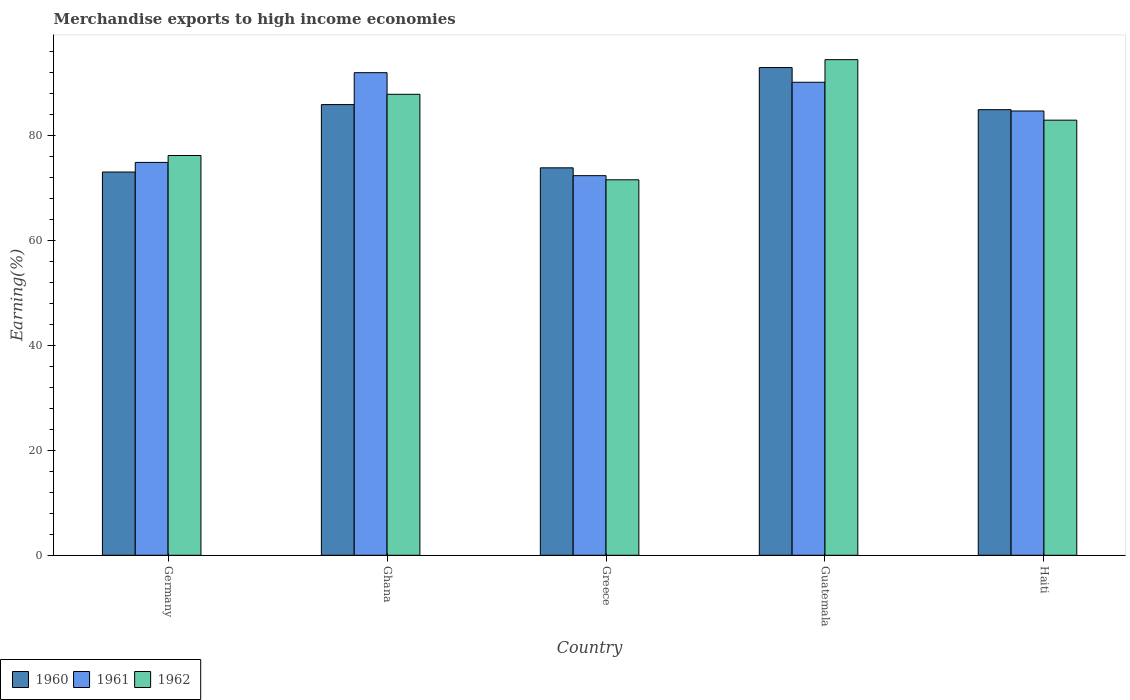How many different coloured bars are there?
Your response must be concise. 3. How many groups of bars are there?
Offer a terse response. 5. Are the number of bars per tick equal to the number of legend labels?
Offer a terse response. Yes. Are the number of bars on each tick of the X-axis equal?
Ensure brevity in your answer.  Yes. How many bars are there on the 4th tick from the left?
Ensure brevity in your answer.  3. In how many cases, is the number of bars for a given country not equal to the number of legend labels?
Keep it short and to the point. 0. What is the percentage of amount earned from merchandise exports in 1962 in Haiti?
Provide a short and direct response. 82.89. Across all countries, what is the maximum percentage of amount earned from merchandise exports in 1960?
Offer a very short reply. 92.91. Across all countries, what is the minimum percentage of amount earned from merchandise exports in 1961?
Provide a short and direct response. 72.31. In which country was the percentage of amount earned from merchandise exports in 1960 maximum?
Provide a succinct answer. Guatemala. In which country was the percentage of amount earned from merchandise exports in 1960 minimum?
Make the answer very short. Germany. What is the total percentage of amount earned from merchandise exports in 1960 in the graph?
Make the answer very short. 410.46. What is the difference between the percentage of amount earned from merchandise exports in 1960 in Ghana and that in Greece?
Keep it short and to the point. 12.05. What is the difference between the percentage of amount earned from merchandise exports in 1960 in Germany and the percentage of amount earned from merchandise exports in 1961 in Ghana?
Give a very brief answer. -18.93. What is the average percentage of amount earned from merchandise exports in 1960 per country?
Offer a terse response. 82.09. What is the difference between the percentage of amount earned from merchandise exports of/in 1960 and percentage of amount earned from merchandise exports of/in 1961 in Germany?
Provide a succinct answer. -1.83. In how many countries, is the percentage of amount earned from merchandise exports in 1962 greater than 16 %?
Provide a succinct answer. 5. What is the ratio of the percentage of amount earned from merchandise exports in 1961 in Ghana to that in Guatemala?
Keep it short and to the point. 1.02. Is the difference between the percentage of amount earned from merchandise exports in 1960 in Germany and Haiti greater than the difference between the percentage of amount earned from merchandise exports in 1961 in Germany and Haiti?
Offer a very short reply. No. What is the difference between the highest and the second highest percentage of amount earned from merchandise exports in 1962?
Make the answer very short. -11.53. What is the difference between the highest and the lowest percentage of amount earned from merchandise exports in 1961?
Your answer should be very brief. 19.62. In how many countries, is the percentage of amount earned from merchandise exports in 1960 greater than the average percentage of amount earned from merchandise exports in 1960 taken over all countries?
Offer a terse response. 3. Is the sum of the percentage of amount earned from merchandise exports in 1962 in Greece and Guatemala greater than the maximum percentage of amount earned from merchandise exports in 1960 across all countries?
Ensure brevity in your answer.  Yes. What does the 1st bar from the left in Ghana represents?
Ensure brevity in your answer.  1960. What does the 3rd bar from the right in Germany represents?
Your answer should be very brief. 1960. How many bars are there?
Your answer should be very brief. 15. Are the values on the major ticks of Y-axis written in scientific E-notation?
Make the answer very short. No. Does the graph contain grids?
Give a very brief answer. No. Where does the legend appear in the graph?
Keep it short and to the point. Bottom left. How many legend labels are there?
Ensure brevity in your answer.  3. What is the title of the graph?
Provide a succinct answer. Merchandise exports to high income economies. Does "1974" appear as one of the legend labels in the graph?
Provide a succinct answer. No. What is the label or title of the X-axis?
Provide a short and direct response. Country. What is the label or title of the Y-axis?
Make the answer very short. Earning(%). What is the Earning(%) in 1960 in Germany?
Your response must be concise. 73.01. What is the Earning(%) in 1961 in Germany?
Your answer should be very brief. 74.84. What is the Earning(%) in 1962 in Germany?
Your answer should be very brief. 76.15. What is the Earning(%) of 1960 in Ghana?
Keep it short and to the point. 85.85. What is the Earning(%) of 1961 in Ghana?
Provide a succinct answer. 91.93. What is the Earning(%) in 1962 in Ghana?
Ensure brevity in your answer.  87.82. What is the Earning(%) in 1960 in Greece?
Your answer should be compact. 73.81. What is the Earning(%) of 1961 in Greece?
Offer a terse response. 72.31. What is the Earning(%) in 1962 in Greece?
Provide a short and direct response. 71.53. What is the Earning(%) in 1960 in Guatemala?
Keep it short and to the point. 92.91. What is the Earning(%) in 1961 in Guatemala?
Offer a very short reply. 90.11. What is the Earning(%) in 1962 in Guatemala?
Keep it short and to the point. 94.41. What is the Earning(%) of 1960 in Haiti?
Make the answer very short. 84.88. What is the Earning(%) in 1961 in Haiti?
Offer a very short reply. 84.63. What is the Earning(%) of 1962 in Haiti?
Provide a succinct answer. 82.89. Across all countries, what is the maximum Earning(%) in 1960?
Provide a succinct answer. 92.91. Across all countries, what is the maximum Earning(%) in 1961?
Provide a short and direct response. 91.93. Across all countries, what is the maximum Earning(%) in 1962?
Give a very brief answer. 94.41. Across all countries, what is the minimum Earning(%) of 1960?
Your answer should be very brief. 73.01. Across all countries, what is the minimum Earning(%) in 1961?
Provide a succinct answer. 72.31. Across all countries, what is the minimum Earning(%) of 1962?
Offer a terse response. 71.53. What is the total Earning(%) in 1960 in the graph?
Offer a terse response. 410.46. What is the total Earning(%) of 1961 in the graph?
Make the answer very short. 413.83. What is the total Earning(%) in 1962 in the graph?
Offer a terse response. 412.8. What is the difference between the Earning(%) of 1960 in Germany and that in Ghana?
Ensure brevity in your answer.  -12.85. What is the difference between the Earning(%) in 1961 in Germany and that in Ghana?
Keep it short and to the point. -17.09. What is the difference between the Earning(%) in 1962 in Germany and that in Ghana?
Ensure brevity in your answer.  -11.66. What is the difference between the Earning(%) in 1960 in Germany and that in Greece?
Provide a short and direct response. -0.8. What is the difference between the Earning(%) in 1961 in Germany and that in Greece?
Ensure brevity in your answer.  2.52. What is the difference between the Earning(%) of 1962 in Germany and that in Greece?
Ensure brevity in your answer.  4.63. What is the difference between the Earning(%) of 1960 in Germany and that in Guatemala?
Offer a very short reply. -19.9. What is the difference between the Earning(%) of 1961 in Germany and that in Guatemala?
Keep it short and to the point. -15.27. What is the difference between the Earning(%) in 1962 in Germany and that in Guatemala?
Make the answer very short. -18.26. What is the difference between the Earning(%) in 1960 in Germany and that in Haiti?
Your response must be concise. -11.88. What is the difference between the Earning(%) of 1961 in Germany and that in Haiti?
Provide a succinct answer. -9.8. What is the difference between the Earning(%) in 1962 in Germany and that in Haiti?
Ensure brevity in your answer.  -6.73. What is the difference between the Earning(%) of 1960 in Ghana and that in Greece?
Provide a succinct answer. 12.05. What is the difference between the Earning(%) in 1961 in Ghana and that in Greece?
Provide a short and direct response. 19.62. What is the difference between the Earning(%) in 1962 in Ghana and that in Greece?
Make the answer very short. 16.29. What is the difference between the Earning(%) of 1960 in Ghana and that in Guatemala?
Keep it short and to the point. -7.05. What is the difference between the Earning(%) in 1961 in Ghana and that in Guatemala?
Provide a short and direct response. 1.82. What is the difference between the Earning(%) of 1962 in Ghana and that in Guatemala?
Make the answer very short. -6.6. What is the difference between the Earning(%) of 1960 in Ghana and that in Haiti?
Provide a succinct answer. 0.97. What is the difference between the Earning(%) in 1961 in Ghana and that in Haiti?
Give a very brief answer. 7.3. What is the difference between the Earning(%) in 1962 in Ghana and that in Haiti?
Keep it short and to the point. 4.93. What is the difference between the Earning(%) in 1960 in Greece and that in Guatemala?
Give a very brief answer. -19.1. What is the difference between the Earning(%) in 1961 in Greece and that in Guatemala?
Offer a terse response. -17.79. What is the difference between the Earning(%) of 1962 in Greece and that in Guatemala?
Offer a very short reply. -22.89. What is the difference between the Earning(%) of 1960 in Greece and that in Haiti?
Offer a terse response. -11.08. What is the difference between the Earning(%) in 1961 in Greece and that in Haiti?
Keep it short and to the point. -12.32. What is the difference between the Earning(%) of 1962 in Greece and that in Haiti?
Provide a succinct answer. -11.36. What is the difference between the Earning(%) of 1960 in Guatemala and that in Haiti?
Offer a terse response. 8.02. What is the difference between the Earning(%) of 1961 in Guatemala and that in Haiti?
Offer a very short reply. 5.48. What is the difference between the Earning(%) of 1962 in Guatemala and that in Haiti?
Your answer should be very brief. 11.53. What is the difference between the Earning(%) in 1960 in Germany and the Earning(%) in 1961 in Ghana?
Provide a succinct answer. -18.93. What is the difference between the Earning(%) in 1960 in Germany and the Earning(%) in 1962 in Ghana?
Ensure brevity in your answer.  -14.81. What is the difference between the Earning(%) in 1961 in Germany and the Earning(%) in 1962 in Ghana?
Your answer should be compact. -12.98. What is the difference between the Earning(%) of 1960 in Germany and the Earning(%) of 1961 in Greece?
Make the answer very short. 0.69. What is the difference between the Earning(%) of 1960 in Germany and the Earning(%) of 1962 in Greece?
Provide a short and direct response. 1.48. What is the difference between the Earning(%) in 1961 in Germany and the Earning(%) in 1962 in Greece?
Provide a short and direct response. 3.31. What is the difference between the Earning(%) in 1960 in Germany and the Earning(%) in 1961 in Guatemala?
Give a very brief answer. -17.1. What is the difference between the Earning(%) in 1960 in Germany and the Earning(%) in 1962 in Guatemala?
Offer a very short reply. -21.41. What is the difference between the Earning(%) in 1961 in Germany and the Earning(%) in 1962 in Guatemala?
Provide a short and direct response. -19.58. What is the difference between the Earning(%) of 1960 in Germany and the Earning(%) of 1961 in Haiti?
Keep it short and to the point. -11.63. What is the difference between the Earning(%) of 1960 in Germany and the Earning(%) of 1962 in Haiti?
Provide a succinct answer. -9.88. What is the difference between the Earning(%) of 1961 in Germany and the Earning(%) of 1962 in Haiti?
Your answer should be compact. -8.05. What is the difference between the Earning(%) in 1960 in Ghana and the Earning(%) in 1961 in Greece?
Ensure brevity in your answer.  13.54. What is the difference between the Earning(%) in 1960 in Ghana and the Earning(%) in 1962 in Greece?
Your response must be concise. 14.33. What is the difference between the Earning(%) in 1961 in Ghana and the Earning(%) in 1962 in Greece?
Keep it short and to the point. 20.41. What is the difference between the Earning(%) of 1960 in Ghana and the Earning(%) of 1961 in Guatemala?
Your answer should be compact. -4.25. What is the difference between the Earning(%) of 1960 in Ghana and the Earning(%) of 1962 in Guatemala?
Offer a very short reply. -8.56. What is the difference between the Earning(%) of 1961 in Ghana and the Earning(%) of 1962 in Guatemala?
Make the answer very short. -2.48. What is the difference between the Earning(%) of 1960 in Ghana and the Earning(%) of 1961 in Haiti?
Your answer should be compact. 1.22. What is the difference between the Earning(%) of 1960 in Ghana and the Earning(%) of 1962 in Haiti?
Your answer should be very brief. 2.97. What is the difference between the Earning(%) of 1961 in Ghana and the Earning(%) of 1962 in Haiti?
Provide a succinct answer. 9.05. What is the difference between the Earning(%) of 1960 in Greece and the Earning(%) of 1961 in Guatemala?
Your response must be concise. -16.3. What is the difference between the Earning(%) of 1960 in Greece and the Earning(%) of 1962 in Guatemala?
Keep it short and to the point. -20.61. What is the difference between the Earning(%) of 1961 in Greece and the Earning(%) of 1962 in Guatemala?
Offer a very short reply. -22.1. What is the difference between the Earning(%) in 1960 in Greece and the Earning(%) in 1961 in Haiti?
Offer a very short reply. -10.83. What is the difference between the Earning(%) of 1960 in Greece and the Earning(%) of 1962 in Haiti?
Keep it short and to the point. -9.08. What is the difference between the Earning(%) in 1961 in Greece and the Earning(%) in 1962 in Haiti?
Offer a very short reply. -10.57. What is the difference between the Earning(%) of 1960 in Guatemala and the Earning(%) of 1961 in Haiti?
Offer a terse response. 8.27. What is the difference between the Earning(%) of 1960 in Guatemala and the Earning(%) of 1962 in Haiti?
Provide a succinct answer. 10.02. What is the difference between the Earning(%) of 1961 in Guatemala and the Earning(%) of 1962 in Haiti?
Give a very brief answer. 7.22. What is the average Earning(%) in 1960 per country?
Give a very brief answer. 82.09. What is the average Earning(%) of 1961 per country?
Provide a succinct answer. 82.77. What is the average Earning(%) of 1962 per country?
Offer a very short reply. 82.56. What is the difference between the Earning(%) in 1960 and Earning(%) in 1961 in Germany?
Your answer should be compact. -1.83. What is the difference between the Earning(%) in 1960 and Earning(%) in 1962 in Germany?
Your response must be concise. -3.15. What is the difference between the Earning(%) of 1961 and Earning(%) of 1962 in Germany?
Keep it short and to the point. -1.32. What is the difference between the Earning(%) of 1960 and Earning(%) of 1961 in Ghana?
Make the answer very short. -6.08. What is the difference between the Earning(%) in 1960 and Earning(%) in 1962 in Ghana?
Your response must be concise. -1.96. What is the difference between the Earning(%) in 1961 and Earning(%) in 1962 in Ghana?
Keep it short and to the point. 4.12. What is the difference between the Earning(%) in 1960 and Earning(%) in 1961 in Greece?
Provide a succinct answer. 1.49. What is the difference between the Earning(%) of 1960 and Earning(%) of 1962 in Greece?
Your response must be concise. 2.28. What is the difference between the Earning(%) in 1961 and Earning(%) in 1962 in Greece?
Your answer should be very brief. 0.79. What is the difference between the Earning(%) of 1960 and Earning(%) of 1961 in Guatemala?
Your answer should be compact. 2.8. What is the difference between the Earning(%) of 1960 and Earning(%) of 1962 in Guatemala?
Your answer should be compact. -1.51. What is the difference between the Earning(%) in 1961 and Earning(%) in 1962 in Guatemala?
Offer a very short reply. -4.3. What is the difference between the Earning(%) in 1960 and Earning(%) in 1961 in Haiti?
Your answer should be compact. 0.25. What is the difference between the Earning(%) in 1960 and Earning(%) in 1962 in Haiti?
Your answer should be compact. 2. What is the difference between the Earning(%) of 1961 and Earning(%) of 1962 in Haiti?
Give a very brief answer. 1.75. What is the ratio of the Earning(%) in 1960 in Germany to that in Ghana?
Keep it short and to the point. 0.85. What is the ratio of the Earning(%) in 1961 in Germany to that in Ghana?
Provide a short and direct response. 0.81. What is the ratio of the Earning(%) of 1962 in Germany to that in Ghana?
Provide a short and direct response. 0.87. What is the ratio of the Earning(%) of 1961 in Germany to that in Greece?
Your answer should be compact. 1.03. What is the ratio of the Earning(%) of 1962 in Germany to that in Greece?
Offer a terse response. 1.06. What is the ratio of the Earning(%) of 1960 in Germany to that in Guatemala?
Provide a short and direct response. 0.79. What is the ratio of the Earning(%) in 1961 in Germany to that in Guatemala?
Offer a very short reply. 0.83. What is the ratio of the Earning(%) of 1962 in Germany to that in Guatemala?
Make the answer very short. 0.81. What is the ratio of the Earning(%) of 1960 in Germany to that in Haiti?
Offer a terse response. 0.86. What is the ratio of the Earning(%) in 1961 in Germany to that in Haiti?
Provide a succinct answer. 0.88. What is the ratio of the Earning(%) of 1962 in Germany to that in Haiti?
Provide a short and direct response. 0.92. What is the ratio of the Earning(%) of 1960 in Ghana to that in Greece?
Your answer should be compact. 1.16. What is the ratio of the Earning(%) in 1961 in Ghana to that in Greece?
Offer a terse response. 1.27. What is the ratio of the Earning(%) of 1962 in Ghana to that in Greece?
Ensure brevity in your answer.  1.23. What is the ratio of the Earning(%) of 1960 in Ghana to that in Guatemala?
Offer a terse response. 0.92. What is the ratio of the Earning(%) in 1961 in Ghana to that in Guatemala?
Offer a terse response. 1.02. What is the ratio of the Earning(%) in 1962 in Ghana to that in Guatemala?
Provide a short and direct response. 0.93. What is the ratio of the Earning(%) in 1960 in Ghana to that in Haiti?
Keep it short and to the point. 1.01. What is the ratio of the Earning(%) in 1961 in Ghana to that in Haiti?
Keep it short and to the point. 1.09. What is the ratio of the Earning(%) in 1962 in Ghana to that in Haiti?
Ensure brevity in your answer.  1.06. What is the ratio of the Earning(%) in 1960 in Greece to that in Guatemala?
Offer a terse response. 0.79. What is the ratio of the Earning(%) in 1961 in Greece to that in Guatemala?
Make the answer very short. 0.8. What is the ratio of the Earning(%) in 1962 in Greece to that in Guatemala?
Make the answer very short. 0.76. What is the ratio of the Earning(%) in 1960 in Greece to that in Haiti?
Offer a very short reply. 0.87. What is the ratio of the Earning(%) of 1961 in Greece to that in Haiti?
Your response must be concise. 0.85. What is the ratio of the Earning(%) in 1962 in Greece to that in Haiti?
Your answer should be very brief. 0.86. What is the ratio of the Earning(%) of 1960 in Guatemala to that in Haiti?
Your answer should be compact. 1.09. What is the ratio of the Earning(%) in 1961 in Guatemala to that in Haiti?
Keep it short and to the point. 1.06. What is the ratio of the Earning(%) of 1962 in Guatemala to that in Haiti?
Provide a succinct answer. 1.14. What is the difference between the highest and the second highest Earning(%) of 1960?
Make the answer very short. 7.05. What is the difference between the highest and the second highest Earning(%) of 1961?
Keep it short and to the point. 1.82. What is the difference between the highest and the second highest Earning(%) of 1962?
Provide a short and direct response. 6.6. What is the difference between the highest and the lowest Earning(%) in 1960?
Make the answer very short. 19.9. What is the difference between the highest and the lowest Earning(%) of 1961?
Ensure brevity in your answer.  19.62. What is the difference between the highest and the lowest Earning(%) of 1962?
Ensure brevity in your answer.  22.89. 